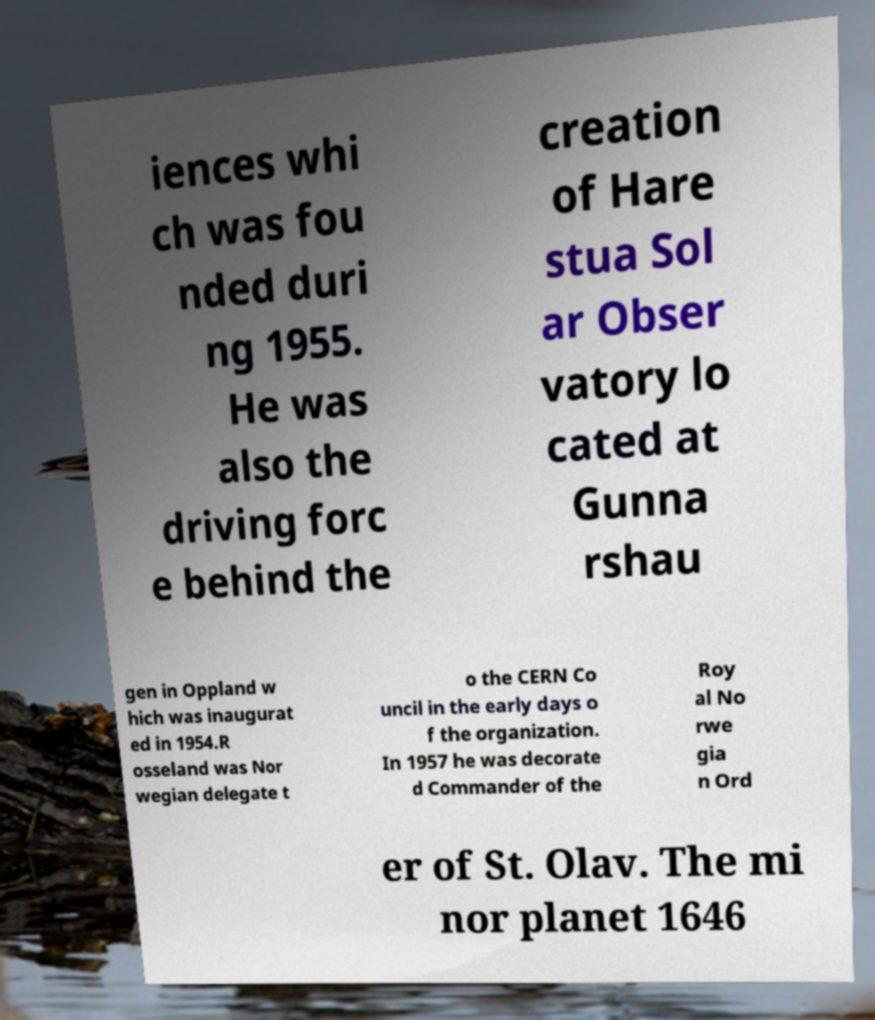Please read and relay the text visible in this image. What does it say? iences whi ch was fou nded duri ng 1955. He was also the driving forc e behind the creation of Hare stua Sol ar Obser vatory lo cated at Gunna rshau gen in Oppland w hich was inaugurat ed in 1954.R osseland was Nor wegian delegate t o the CERN Co uncil in the early days o f the organization. In 1957 he was decorate d Commander of the Roy al No rwe gia n Ord er of St. Olav. The mi nor planet 1646 